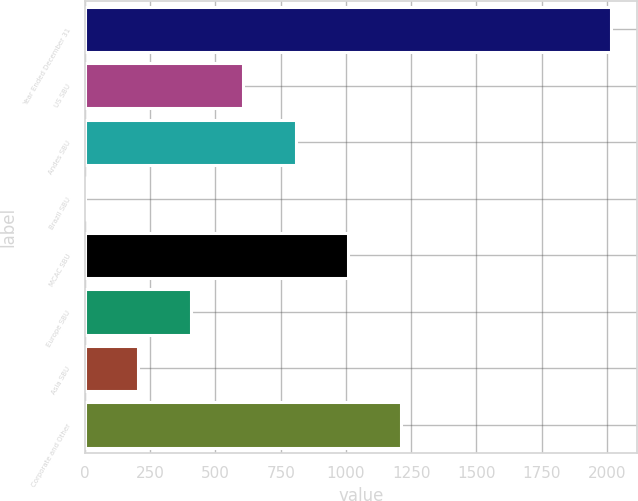Convert chart to OTSL. <chart><loc_0><loc_0><loc_500><loc_500><bar_chart><fcel>Year Ended December 31<fcel>US SBU<fcel>Andes SBU<fcel>Brazil SBU<fcel>MCAC SBU<fcel>Europe SBU<fcel>Asia SBU<fcel>Corporate and Other<nl><fcel>2015<fcel>605.9<fcel>807.2<fcel>2<fcel>1008.5<fcel>404.6<fcel>203.3<fcel>1209.8<nl></chart> 